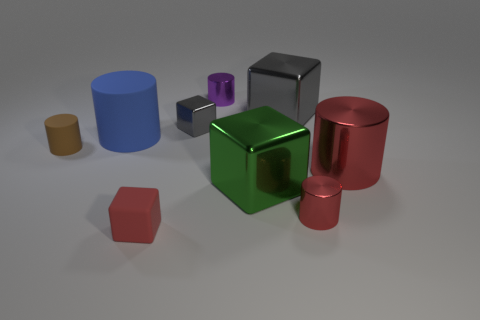Can you tell me about the lighting in the scene? Does it come from a specific direction? The lighting in the scene appears to be soft and diffused, coming from above. This is indicated by the subtle shadows beneath the objects, which are fairly short and extend directly opposite to where each object stands, suggesting a light source situated above the objects. 